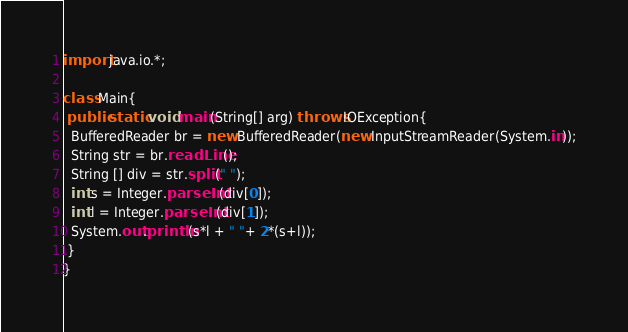Convert code to text. <code><loc_0><loc_0><loc_500><loc_500><_Java_>import java.io.*;

class Main{
 public static void main(String[] arg) throws IOException{
  BufferedReader br = new BufferedReader(new InputStreamReader(System.in));
  String str = br.readLine();
  String [] div = str.split(" ");
  int s = Integer.parseInt(div[0]);
  int l = Integer.parseInt(div[1]);
  System.out.println(s*l + " "+ 2*(s+l));
 }
}</code> 